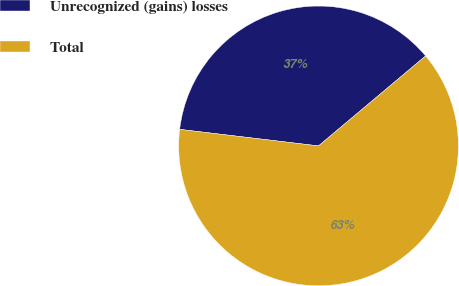Convert chart to OTSL. <chart><loc_0><loc_0><loc_500><loc_500><pie_chart><fcel>Unrecognized (gains) losses<fcel>Total<nl><fcel>36.99%<fcel>63.01%<nl></chart> 